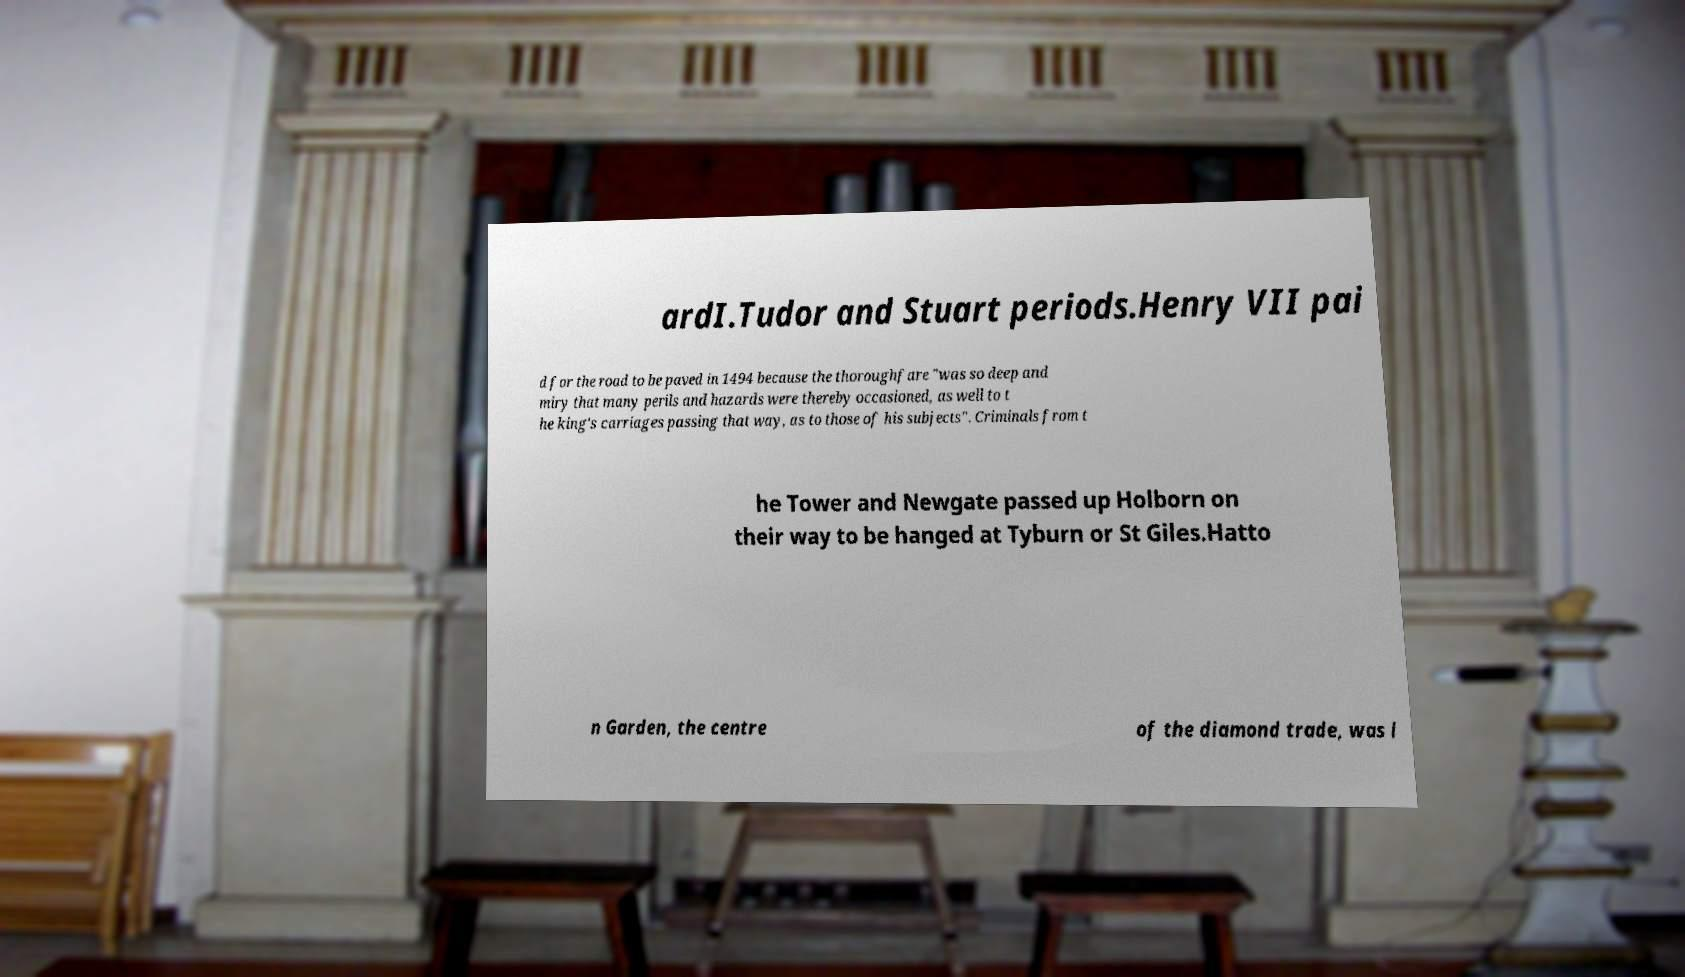Could you extract and type out the text from this image? ardI.Tudor and Stuart periods.Henry VII pai d for the road to be paved in 1494 because the thoroughfare "was so deep and miry that many perils and hazards were thereby occasioned, as well to t he king's carriages passing that way, as to those of his subjects". Criminals from t he Tower and Newgate passed up Holborn on their way to be hanged at Tyburn or St Giles.Hatto n Garden, the centre of the diamond trade, was l 